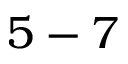Convert formula to latex. <formula><loc_0><loc_0><loc_500><loc_500>5 - 7</formula> 